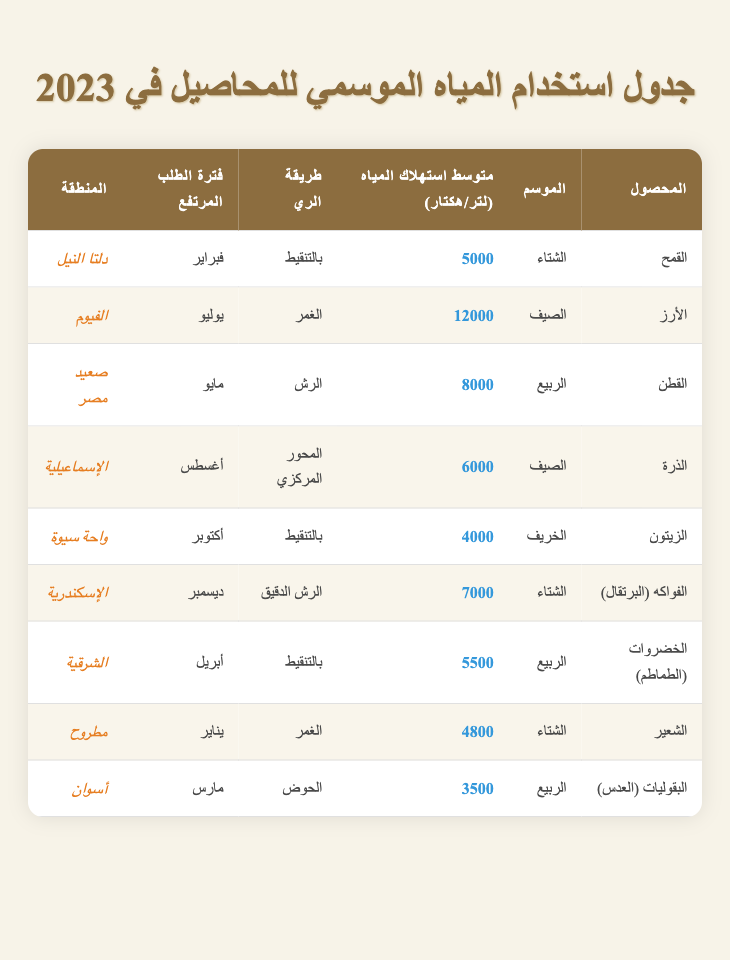ما هي طريقة الري المستخدمة للقمح؟ في الجدول، نجد أن القمح يُروى بطريقة "بالتنقيط".
Answer: بالتنقيط ما هو متوسط استهلاك المياه لكل هكتار للقطن؟ في الجدول، يظهر أن متوسط استهلاك المياه للقطن هو 8000 لتر لكل هكتار.
Answer: 8000 لتر ما هو المحصول الذي يحتاج أكبر كمية من المياه في الصيف؟ في الجدول، الأرز هو المحصول الذي يحتاج لأكبر كمية من المياه في الصيف، بمتوسط استهلاك مياه قدره 12000 لتر لكل هكتار.
Answer: الأرز هل يزرع البقوليات (العدس) في فصل الربيع؟ في الجدول، نرى أن البقوليات (العدس) تُزرع في فصل الربيع، وهذا يدل على أن الجواب صحيح.
Answer: نعم ما هي الفترة ذات الطلب المرتفع للزيتون؟ حسب الجدول، الفترة ذات الطلب المرتفع للزيتون هي في أكتوبر.
Answer: أكتوبر ما هو الانخفاض في متوسط استهلاك المياه بين الفواكه (البرتقال) وزراعة البقوليات (العدس)؟ لتحديد الانخفاض، نقوم بطرح 3500 لتر (العدس) من 7000 لتر (البرتقال)، مما يعطي الفرق 3500 لتر.
Answer: 3500 لتر هل الري بالتنقيط يستخدم لكل من البطاطس والقمح؟ بالنظر إلى الجدول، نجد أن الري بالتنقيط يستخدم للقمح فقط، وليس للبطاطس، مما يجعل الإجابة لا.
Answer: لا ما هو متوسط استهلاك المياه للأعشاب مقارنة بالقمح؟ لا يوجد ذكر للأعشاب في الجدول، لذا سيتعين علينا اعتباره 0 لتر. بينما القمح لديه 5000 لتر، لذا فإن المتغير الوحيد هنا هو القمح.
Answer: 5000 لتر ما هو أكبر محصول في استهلاك المياه في فصل الشتاء؟ في الجدول، نجد أن الفواكه (البرتقال) لها استهلاك قدره 7000 لتر، وهو أعلى من القمح والشعير، لذا فإن الإجابة هي الفواكه (البرتقال).
Answer: الفواكه (البرتقال) 